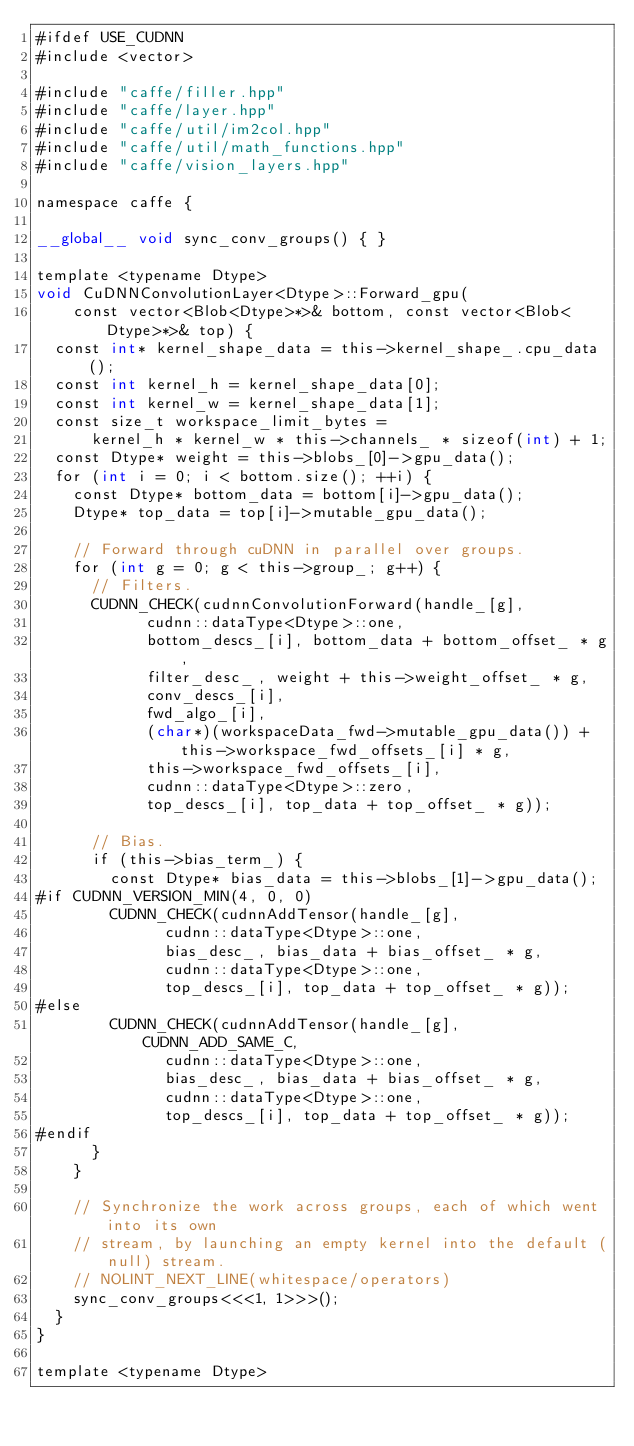<code> <loc_0><loc_0><loc_500><loc_500><_Cuda_>#ifdef USE_CUDNN
#include <vector>

#include "caffe/filler.hpp"
#include "caffe/layer.hpp"
#include "caffe/util/im2col.hpp"
#include "caffe/util/math_functions.hpp"
#include "caffe/vision_layers.hpp"

namespace caffe {

__global__ void sync_conv_groups() { }

template <typename Dtype>
void CuDNNConvolutionLayer<Dtype>::Forward_gpu(
    const vector<Blob<Dtype>*>& bottom, const vector<Blob<Dtype>*>& top) {
  const int* kernel_shape_data = this->kernel_shape_.cpu_data();
  const int kernel_h = kernel_shape_data[0];
  const int kernel_w = kernel_shape_data[1];
  const size_t workspace_limit_bytes =
      kernel_h * kernel_w * this->channels_ * sizeof(int) + 1;
  const Dtype* weight = this->blobs_[0]->gpu_data();
  for (int i = 0; i < bottom.size(); ++i) {
    const Dtype* bottom_data = bottom[i]->gpu_data();
    Dtype* top_data = top[i]->mutable_gpu_data();

    // Forward through cuDNN in parallel over groups.
    for (int g = 0; g < this->group_; g++) {
      // Filters.
      CUDNN_CHECK(cudnnConvolutionForward(handle_[g],
            cudnn::dataType<Dtype>::one,
            bottom_descs_[i], bottom_data + bottom_offset_ * g,
            filter_desc_, weight + this->weight_offset_ * g,
            conv_descs_[i],
            fwd_algo_[i],
            (char*)(workspaceData_fwd->mutable_gpu_data()) + this->workspace_fwd_offsets_[i] * g,
            this->workspace_fwd_offsets_[i],
            cudnn::dataType<Dtype>::zero,
            top_descs_[i], top_data + top_offset_ * g));

      // Bias.
      if (this->bias_term_) {
        const Dtype* bias_data = this->blobs_[1]->gpu_data();
#if CUDNN_VERSION_MIN(4, 0, 0)
        CUDNN_CHECK(cudnnAddTensor(handle_[g],
              cudnn::dataType<Dtype>::one,
              bias_desc_, bias_data + bias_offset_ * g,
              cudnn::dataType<Dtype>::one,
              top_descs_[i], top_data + top_offset_ * g));
#else
        CUDNN_CHECK(cudnnAddTensor(handle_[g], CUDNN_ADD_SAME_C,
              cudnn::dataType<Dtype>::one,
              bias_desc_, bias_data + bias_offset_ * g,
              cudnn::dataType<Dtype>::one,
              top_descs_[i], top_data + top_offset_ * g));
#endif
      }
    }

    // Synchronize the work across groups, each of which went into its own
    // stream, by launching an empty kernel into the default (null) stream.
    // NOLINT_NEXT_LINE(whitespace/operators)
    sync_conv_groups<<<1, 1>>>();
  }
}

template <typename Dtype></code> 